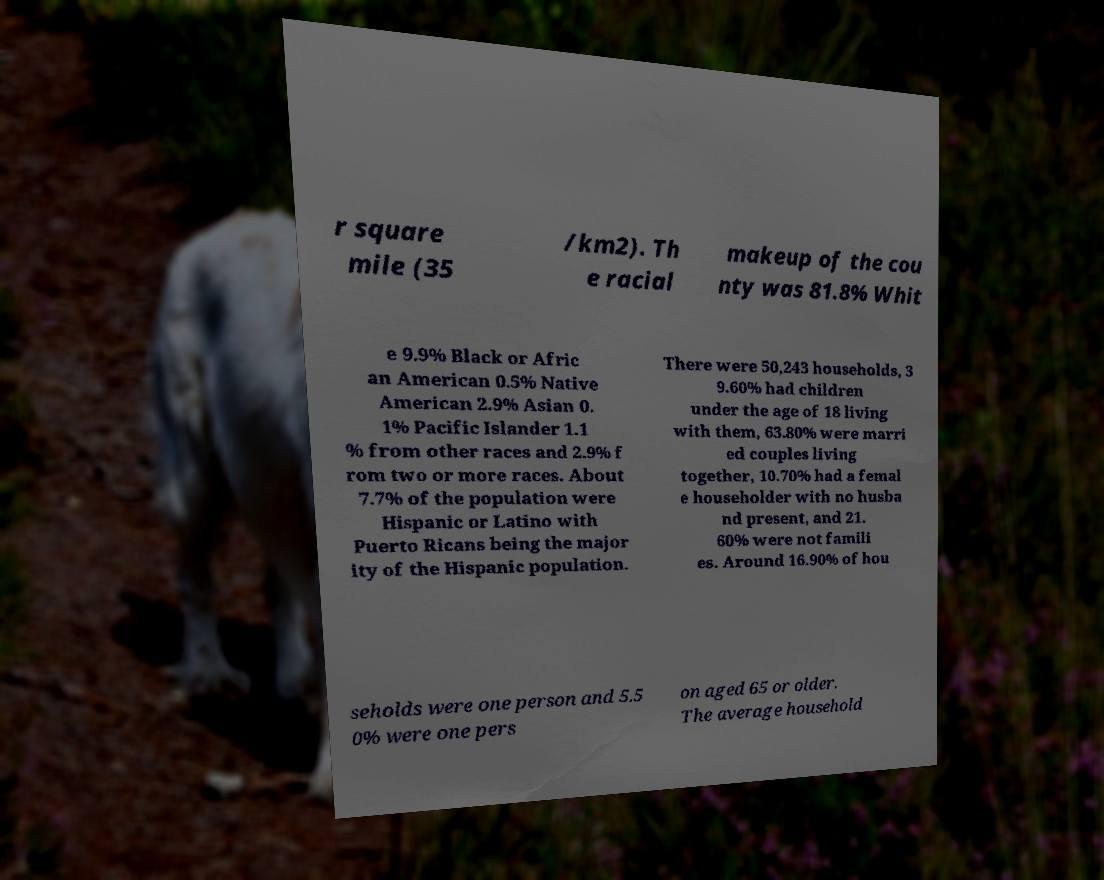Can you accurately transcribe the text from the provided image for me? r square mile (35 /km2). Th e racial makeup of the cou nty was 81.8% Whit e 9.9% Black or Afric an American 0.5% Native American 2.9% Asian 0. 1% Pacific Islander 1.1 % from other races and 2.9% f rom two or more races. About 7.7% of the population were Hispanic or Latino with Puerto Ricans being the major ity of the Hispanic population. There were 50,243 households, 3 9.60% had children under the age of 18 living with them, 63.80% were marri ed couples living together, 10.70% had a femal e householder with no husba nd present, and 21. 60% were not famili es. Around 16.90% of hou seholds were one person and 5.5 0% were one pers on aged 65 or older. The average household 